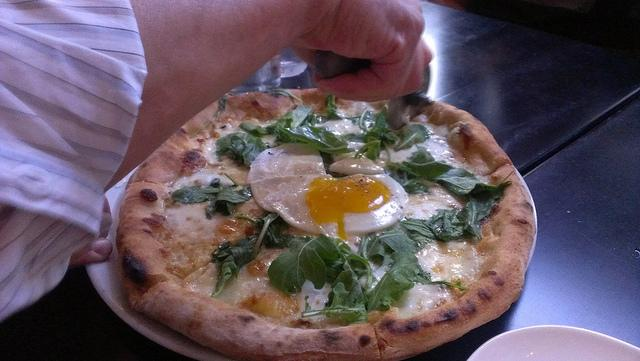What animal did the topmost ingredient come from? chicken 